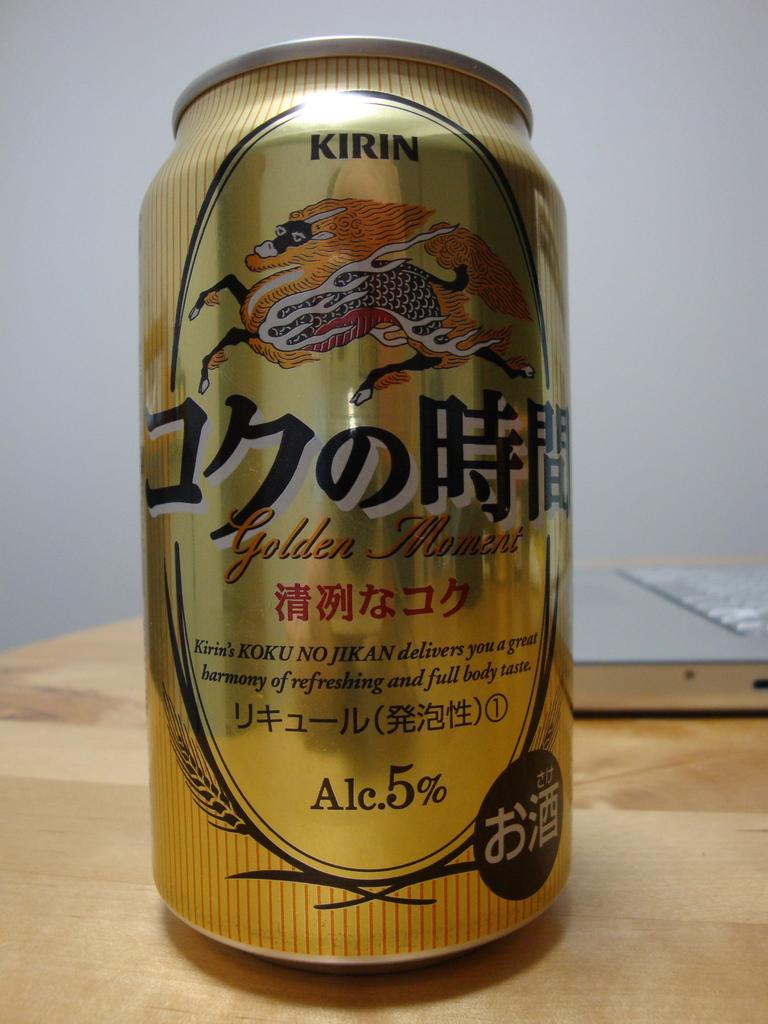Provide a one-sentence caption for the provided image. Can of Kirin Golden Moment containing 5% alcohol. 